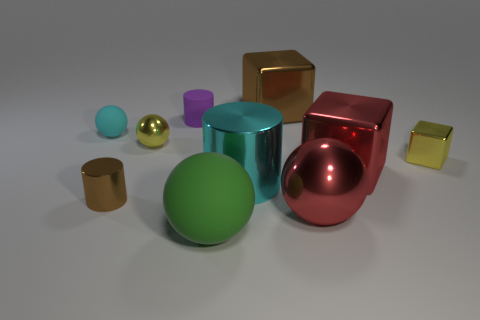Subtract all brown metallic cylinders. How many cylinders are left? 2 Subtract 3 spheres. How many spheres are left? 1 Subtract all big blue objects. Subtract all tiny purple matte cylinders. How many objects are left? 9 Add 8 big cyan things. How many big cyan things are left? 9 Add 5 cyan matte spheres. How many cyan matte spheres exist? 6 Subtract all purple cylinders. How many cylinders are left? 2 Subtract 0 green cubes. How many objects are left? 10 Subtract all balls. How many objects are left? 6 Subtract all green blocks. Subtract all cyan spheres. How many blocks are left? 3 Subtract all yellow balls. How many green cubes are left? 0 